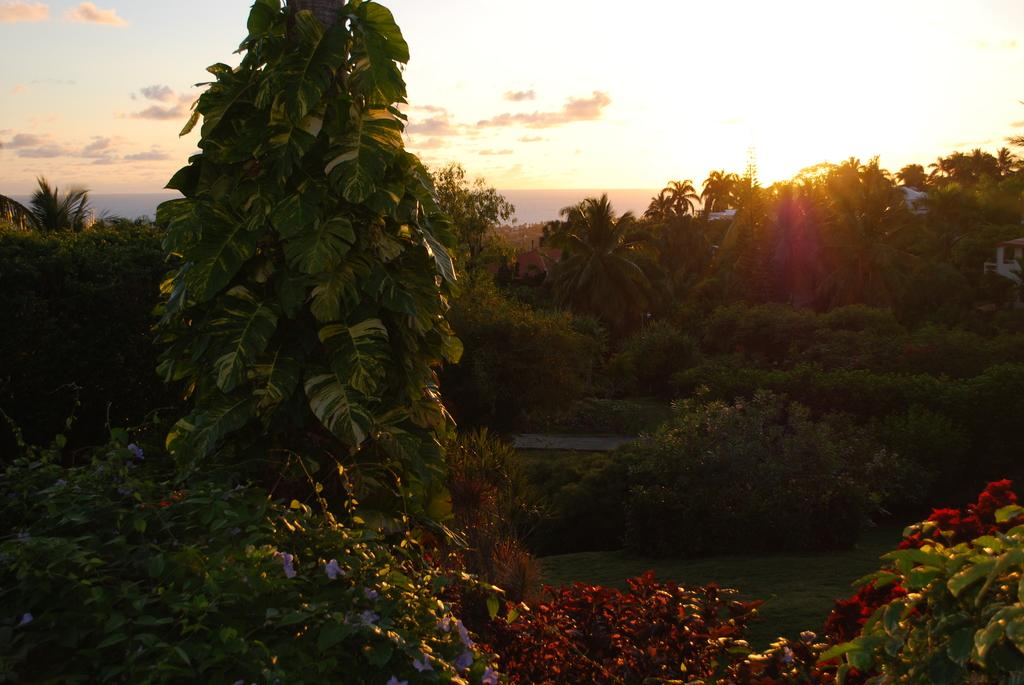What type of vegetation can be seen in the image? There are trees in the image. What type of structure is present in the image? There is a house in the image. What can be seen in the sky in the image? There are clouds in the sky, and the sun is visible. Can you tell me how many muscles are visible in the image? There are no muscles visible in the image; it features trees, a house, clouds, and the sun. What type of mist can be seen in the image? There is no mist present in the image; it features trees, a house, clouds, and the sun. 